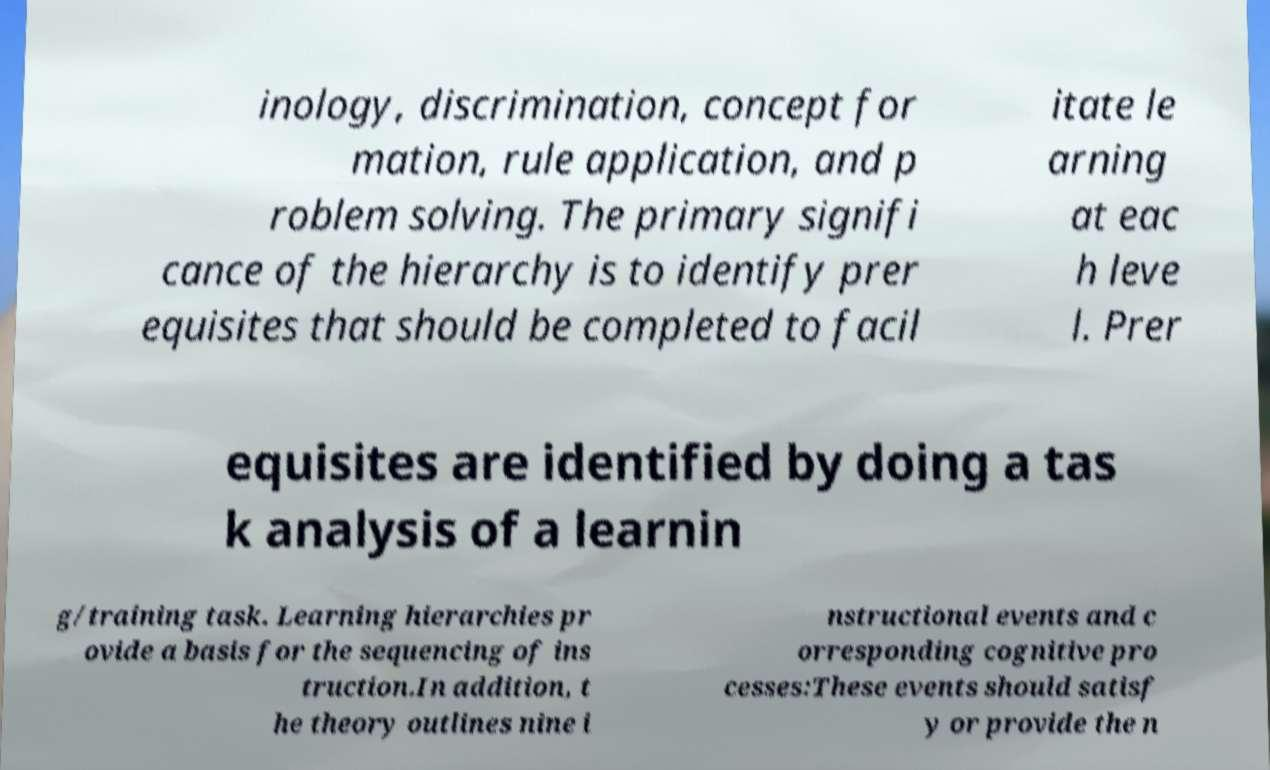What messages or text are displayed in this image? I need them in a readable, typed format. inology, discrimination, concept for mation, rule application, and p roblem solving. The primary signifi cance of the hierarchy is to identify prer equisites that should be completed to facil itate le arning at eac h leve l. Prer equisites are identified by doing a tas k analysis of a learnin g/training task. Learning hierarchies pr ovide a basis for the sequencing of ins truction.In addition, t he theory outlines nine i nstructional events and c orresponding cognitive pro cesses:These events should satisf y or provide the n 